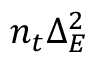<formula> <loc_0><loc_0><loc_500><loc_500>n _ { t } \Delta _ { E } ^ { 2 }</formula> 